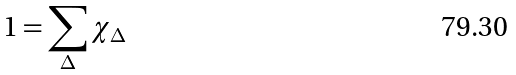Convert formula to latex. <formula><loc_0><loc_0><loc_500><loc_500>1 = \sum _ { \Delta } \chi _ { \Delta }</formula> 